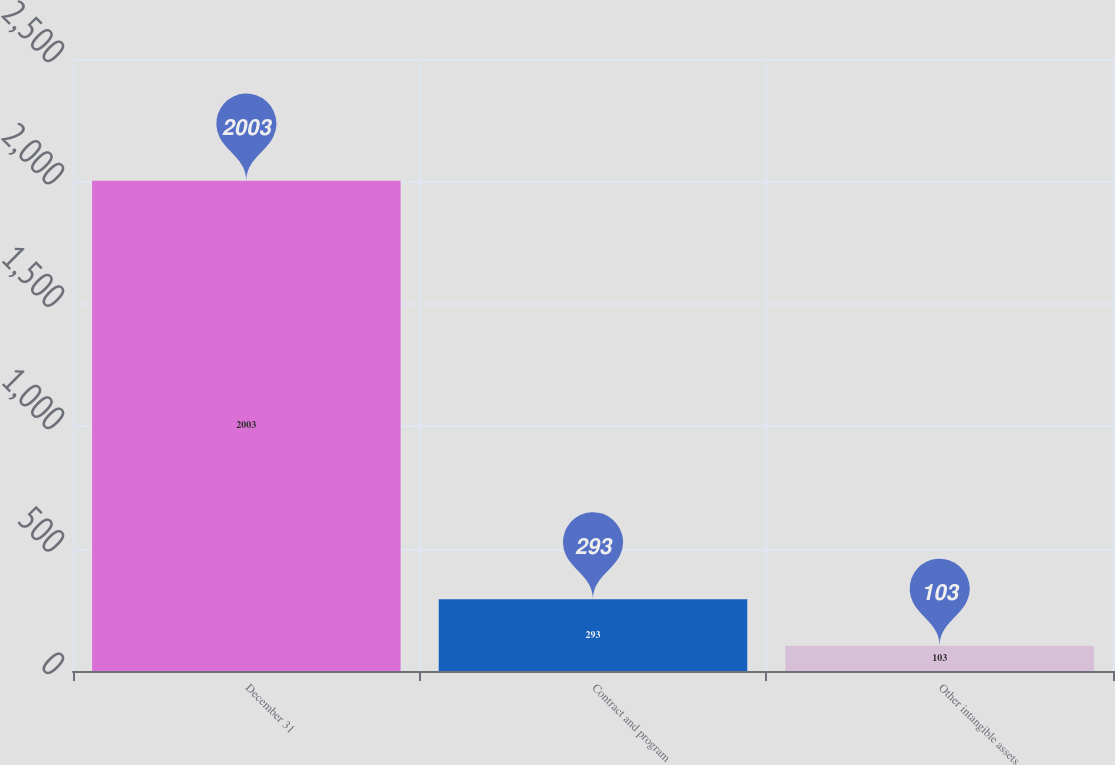Convert chart to OTSL. <chart><loc_0><loc_0><loc_500><loc_500><bar_chart><fcel>December 31<fcel>Contract and program<fcel>Other intangible assets<nl><fcel>2003<fcel>293<fcel>103<nl></chart> 